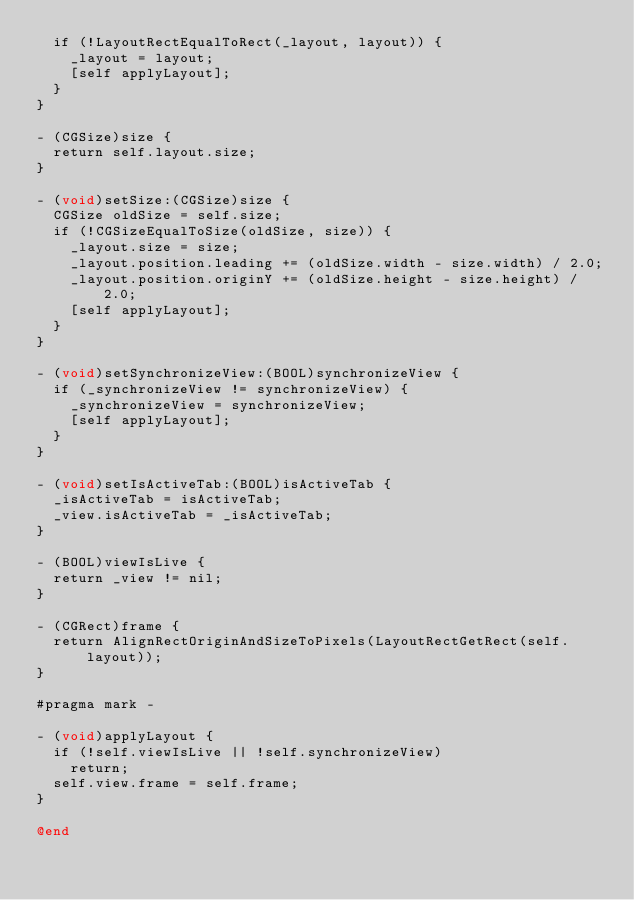Convert code to text. <code><loc_0><loc_0><loc_500><loc_500><_ObjectiveC_>  if (!LayoutRectEqualToRect(_layout, layout)) {
    _layout = layout;
    [self applyLayout];
  }
}

- (CGSize)size {
  return self.layout.size;
}

- (void)setSize:(CGSize)size {
  CGSize oldSize = self.size;
  if (!CGSizeEqualToSize(oldSize, size)) {
    _layout.size = size;
    _layout.position.leading += (oldSize.width - size.width) / 2.0;
    _layout.position.originY += (oldSize.height - size.height) / 2.0;
    [self applyLayout];
  }
}

- (void)setSynchronizeView:(BOOL)synchronizeView {
  if (_synchronizeView != synchronizeView) {
    _synchronizeView = synchronizeView;
    [self applyLayout];
  }
}

- (void)setIsActiveTab:(BOOL)isActiveTab {
  _isActiveTab = isActiveTab;
  _view.isActiveTab = _isActiveTab;
}

- (BOOL)viewIsLive {
  return _view != nil;
}

- (CGRect)frame {
  return AlignRectOriginAndSizeToPixels(LayoutRectGetRect(self.layout));
}

#pragma mark -

- (void)applyLayout {
  if (!self.viewIsLive || !self.synchronizeView)
    return;
  self.view.frame = self.frame;
}

@end
</code> 